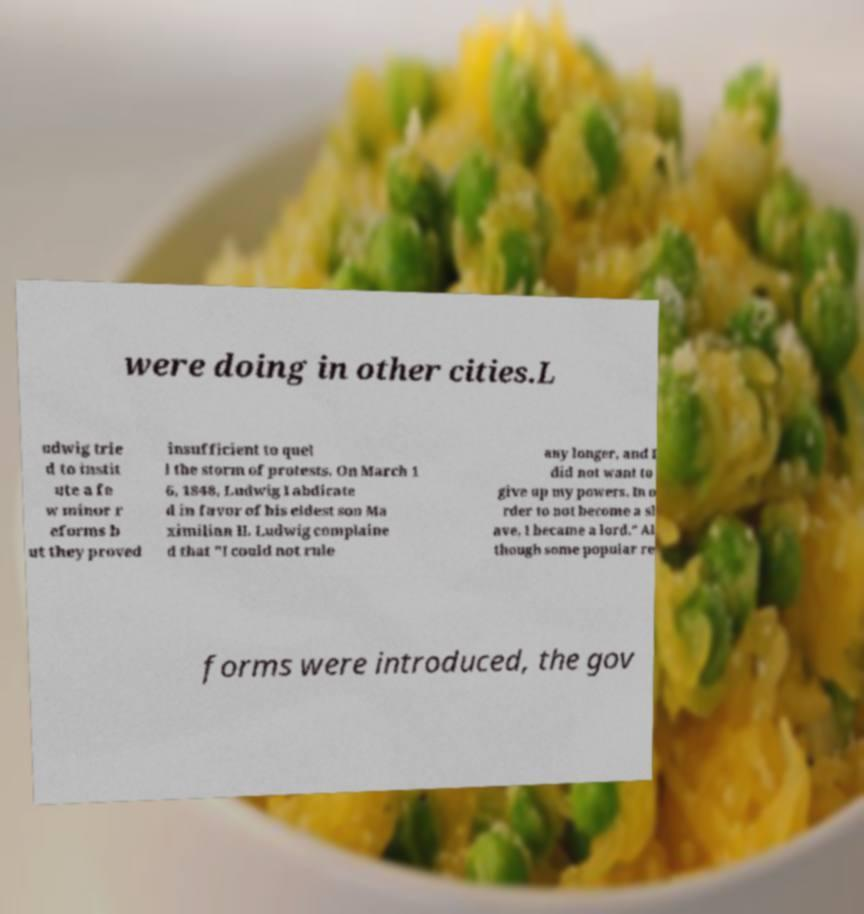I need the written content from this picture converted into text. Can you do that? were doing in other cities.L udwig trie d to instit ute a fe w minor r eforms b ut they proved insufficient to quel l the storm of protests. On March 1 6, 1848, Ludwig I abdicate d in favor of his eldest son Ma ximilian II. Ludwig complaine d that "I could not rule any longer, and I did not want to give up my powers. In o rder to not become a sl ave, I became a lord." Al though some popular re forms were introduced, the gov 